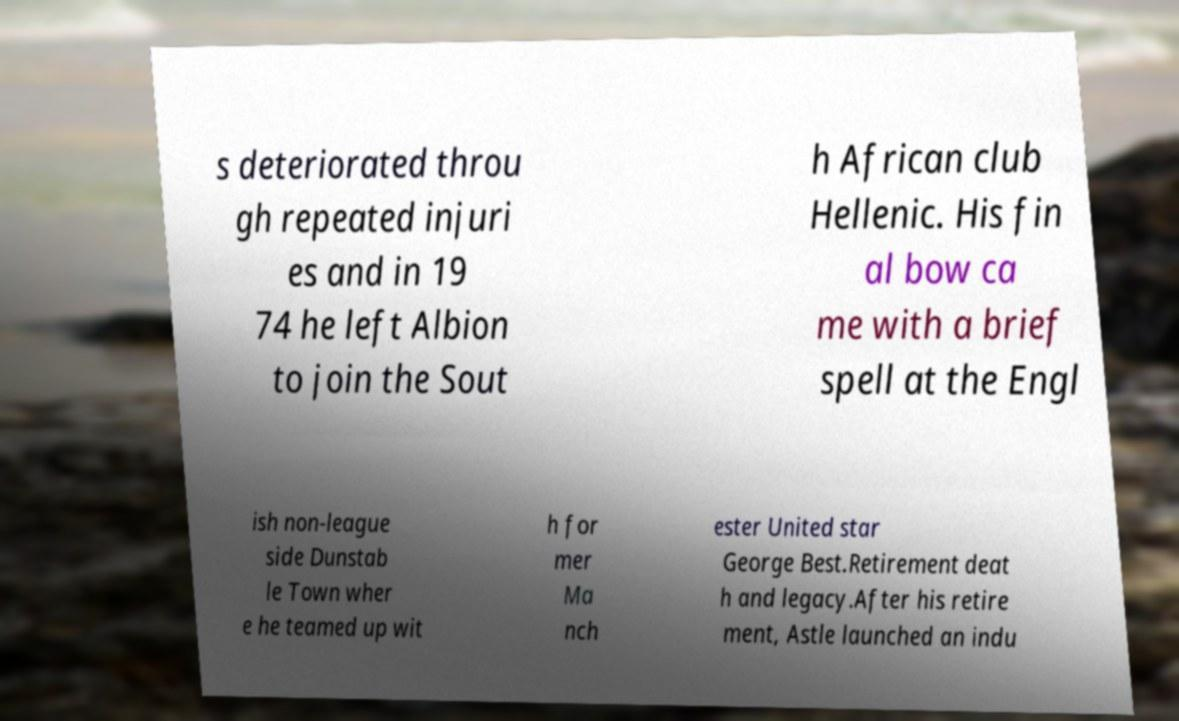Could you extract and type out the text from this image? s deteriorated throu gh repeated injuri es and in 19 74 he left Albion to join the Sout h African club Hellenic. His fin al bow ca me with a brief spell at the Engl ish non-league side Dunstab le Town wher e he teamed up wit h for mer Ma nch ester United star George Best.Retirement deat h and legacy.After his retire ment, Astle launched an indu 